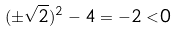Convert formula to latex. <formula><loc_0><loc_0><loc_500><loc_500>( \pm \sqrt { 2 } ) ^ { 2 } - 4 = - 2 < 0</formula> 